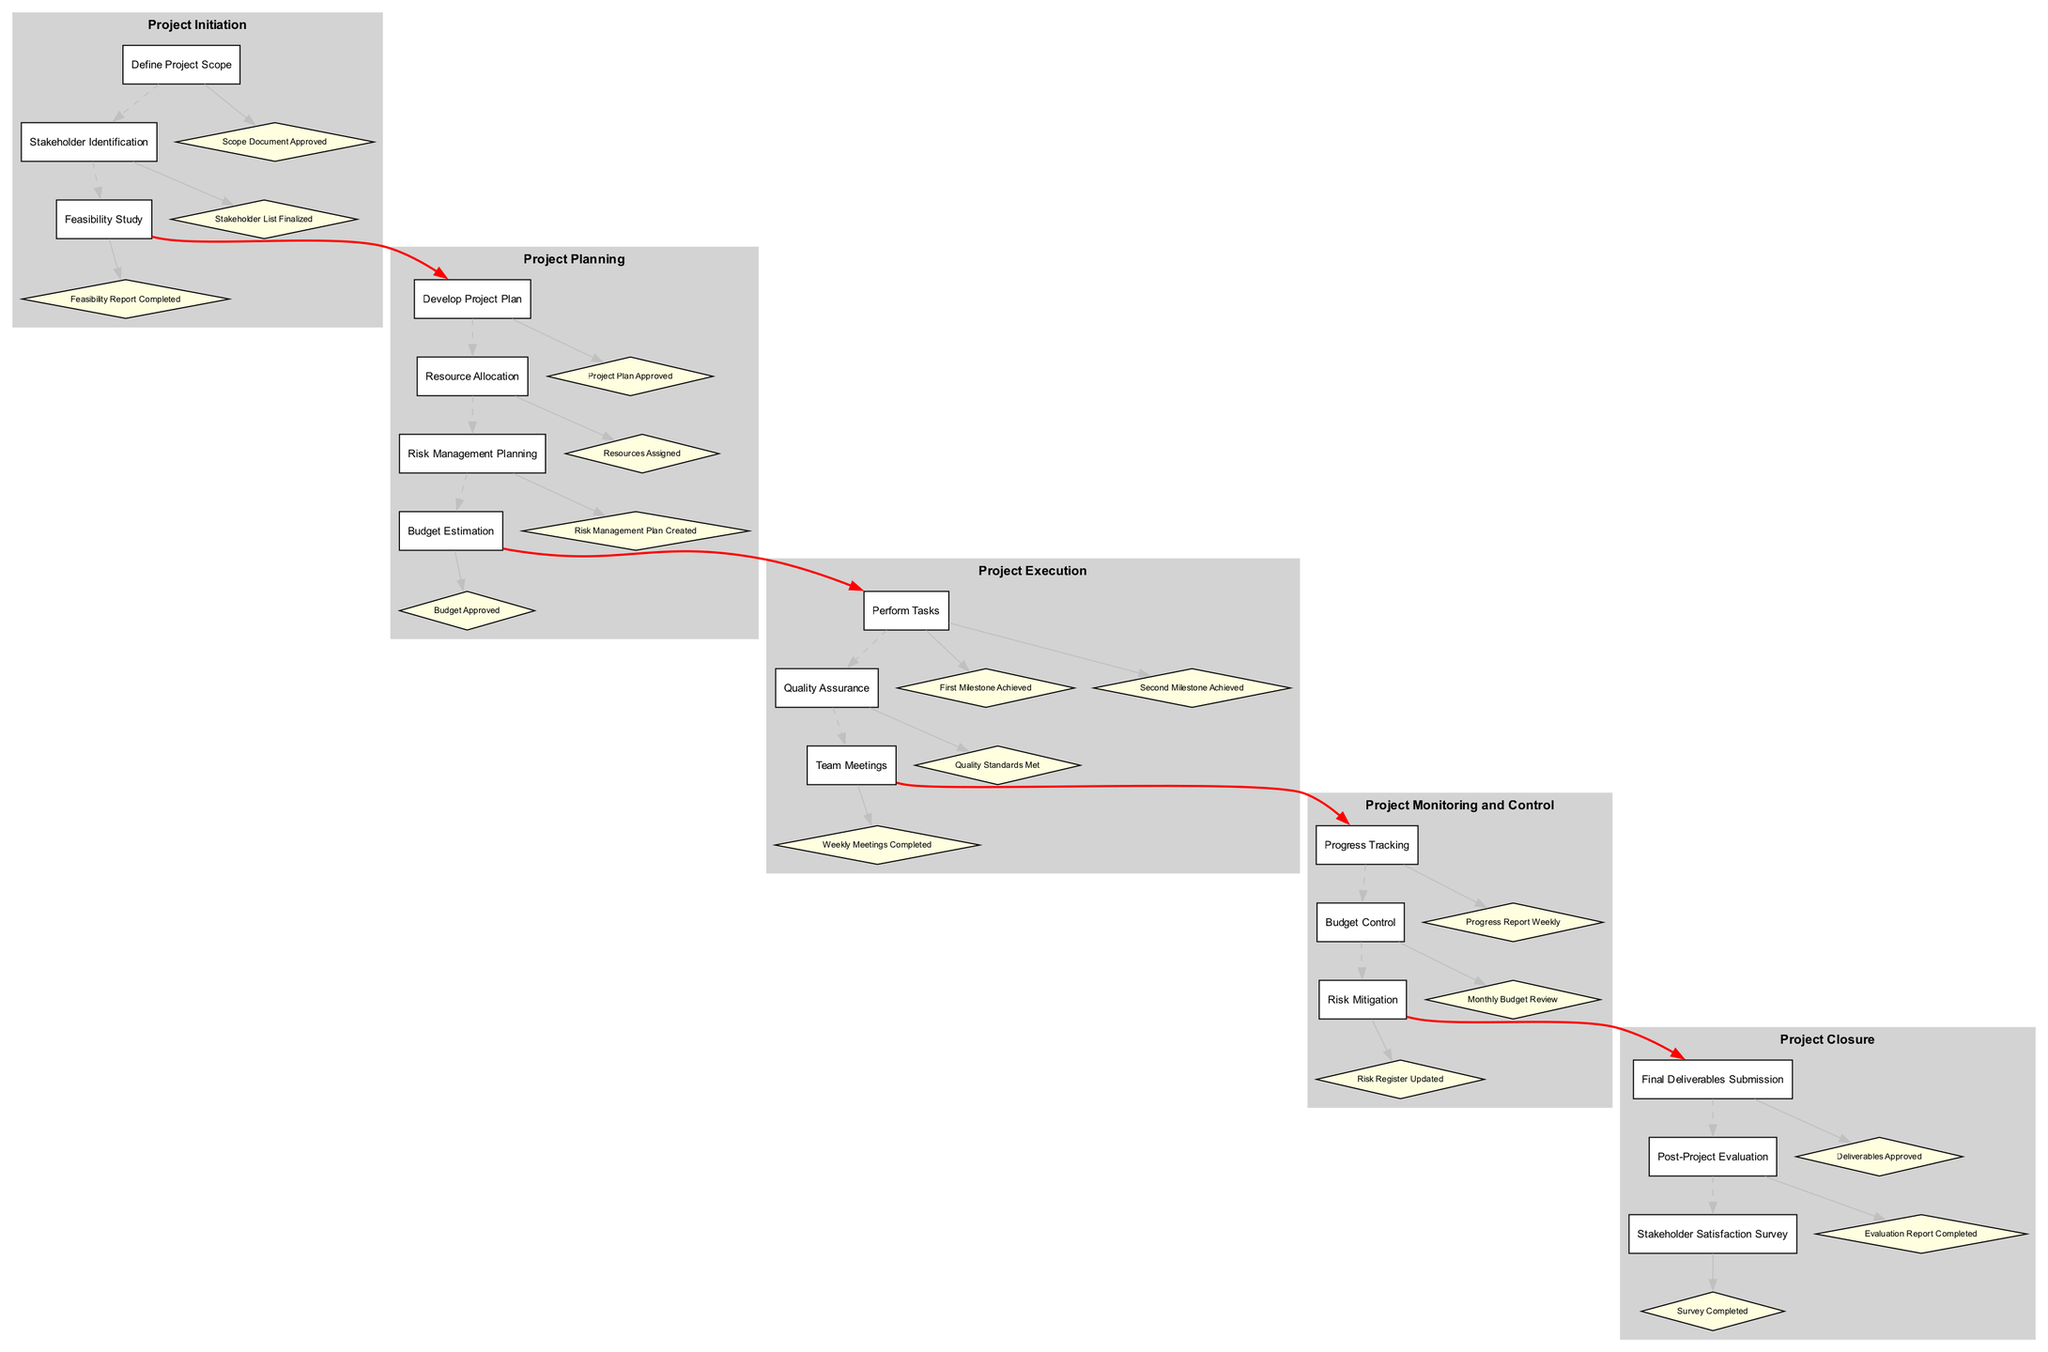What is the first task in the Project Planning phase? The Project Planning phase consists of multiple tasks, and the first task listed under it is "Develop Project Plan".
Answer: Develop Project Plan How many tasks are in the Project Initiation phase? There are three tasks specified in the Project Initiation phase: "Define Project Scope", "Stakeholder Identification", and "Feasibility Study".
Answer: 3 What milestone is associated with the task "Quality Assurance"? The task "Quality Assurance" has one associated milestone, which is "Quality Standards Met".
Answer: Quality Standards Met Which phase comes after Project Execution? The diagram shows that after the Project Execution phase, the next phase is "Project Monitoring and Control".
Answer: Project Monitoring and Control How many milestones are listed for the task "Perform Tasks"? The task "Perform Tasks" contains two milestones: "First Milestone Achieved" and "Second Milestone Achieved". Thus, there are two milestones for this task.
Answer: 2 What is the relationship between the last task in Project Planning and the first task in Project Execution? The last task in Project Planning is "Budget Estimation", and it is connected to the first task in Project Execution, which is "Perform Tasks", through a bold red edge. This indicates a direct flow from planning to execution.
Answer: Perform Tasks What is the final milestone of the Project Closure phase? The last task in the Project Closure phase is "Stakeholder Satisfaction Survey" and the final milestone associated with it is "Survey Completed".
Answer: Survey Completed How many phases are there in total? The diagram outlines five distinct phases: Project Initiation, Project Planning, Project Execution, Project Monitoring and Control, and Project Closure, counting them gives a total of five phases.
Answer: 5 What is the milestone for the task "Progress Tracking"? The "Progress Tracking" task has one milestone which is "Progress Report Weekly".
Answer: Progress Report Weekly 